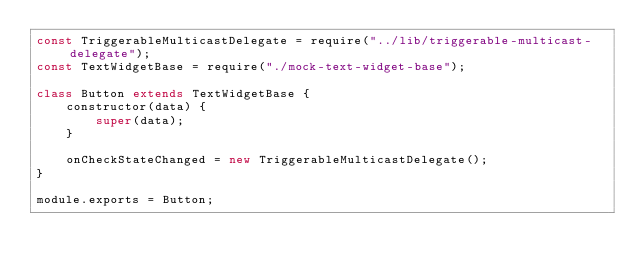Convert code to text. <code><loc_0><loc_0><loc_500><loc_500><_JavaScript_>const TriggerableMulticastDelegate = require("../lib/triggerable-multicast-delegate");
const TextWidgetBase = require("./mock-text-widget-base");

class Button extends TextWidgetBase {
    constructor(data) {
        super(data);
    }

    onCheckStateChanged = new TriggerableMulticastDelegate();
}

module.exports = Button;
</code> 